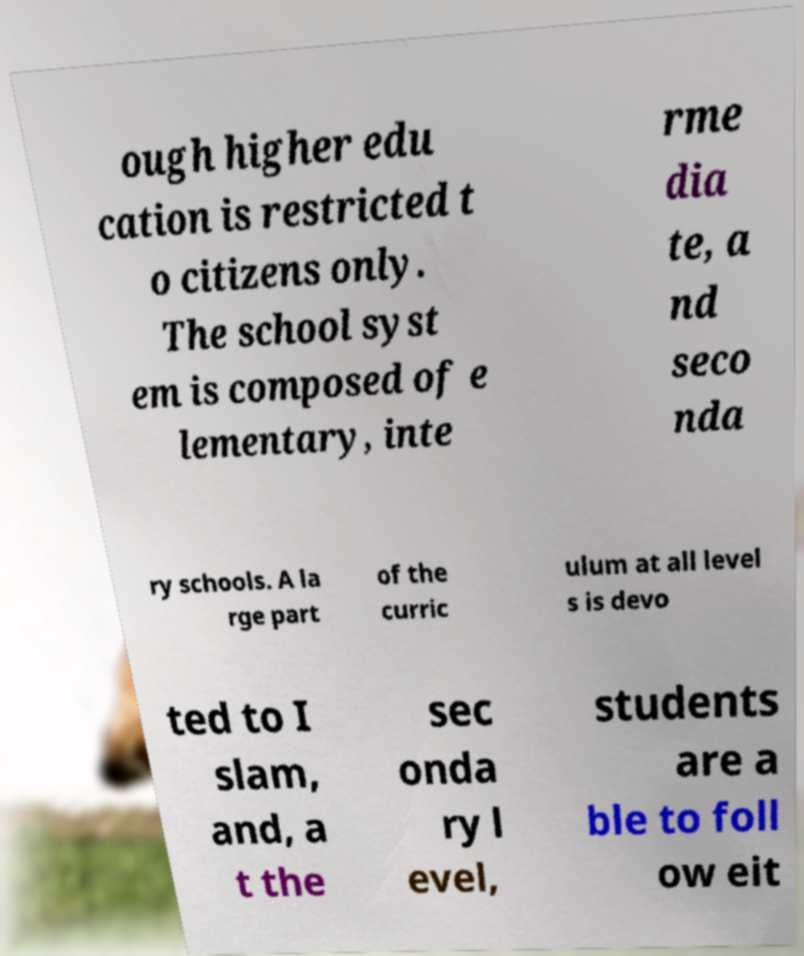What messages or text are displayed in this image? I need them in a readable, typed format. ough higher edu cation is restricted t o citizens only. The school syst em is composed of e lementary, inte rme dia te, a nd seco nda ry schools. A la rge part of the curric ulum at all level s is devo ted to I slam, and, a t the sec onda ry l evel, students are a ble to foll ow eit 